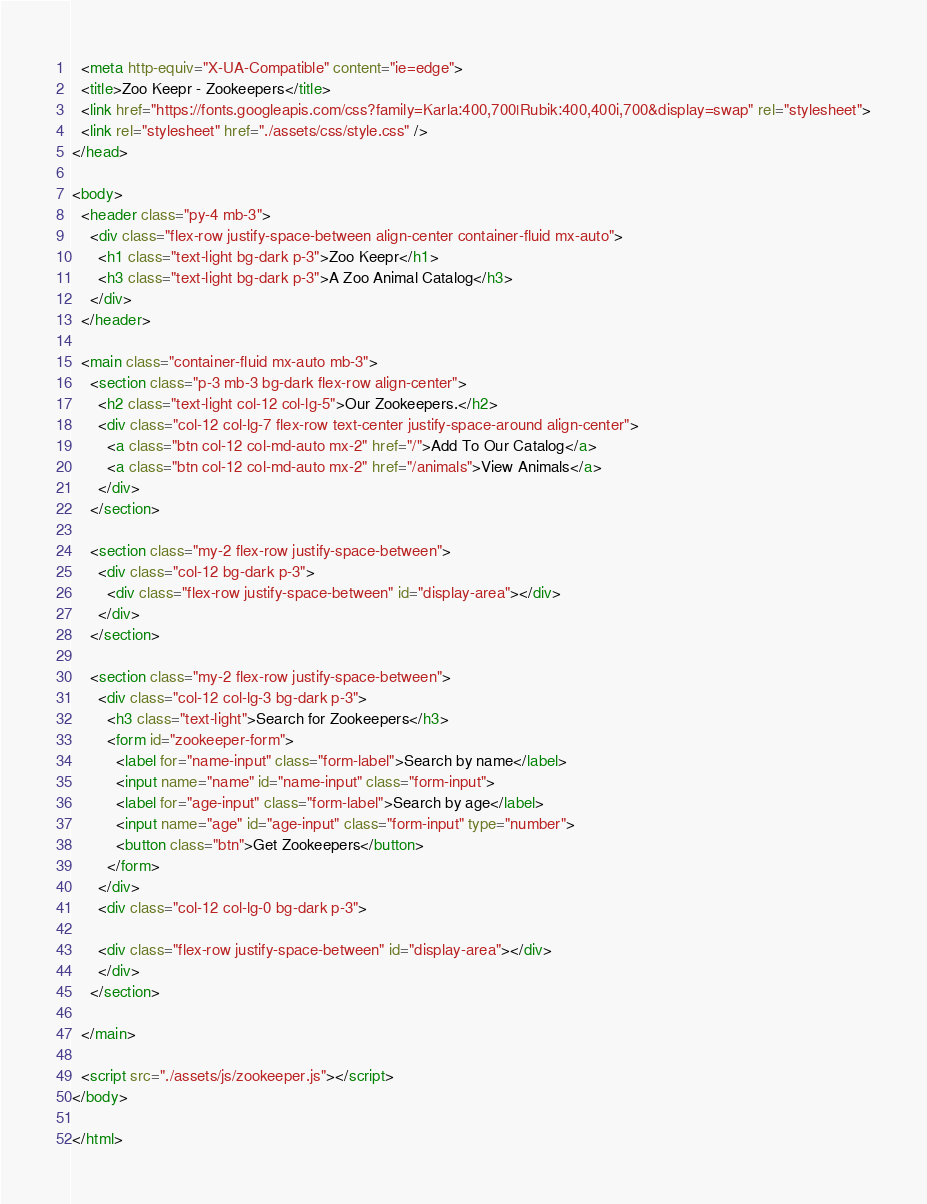Convert code to text. <code><loc_0><loc_0><loc_500><loc_500><_HTML_>  <meta http-equiv="X-UA-Compatible" content="ie=edge">
  <title>Zoo Keepr - Zookeepers</title>
  <link href="https://fonts.googleapis.com/css?family=Karla:400,700|Rubik:400,400i,700&display=swap" rel="stylesheet">
  <link rel="stylesheet" href="./assets/css/style.css" />
</head>

<body>
  <header class="py-4 mb-3">
    <div class="flex-row justify-space-between align-center container-fluid mx-auto">
      <h1 class="text-light bg-dark p-3">Zoo Keepr</h1>
      <h3 class="text-light bg-dark p-3">A Zoo Animal Catalog</h3>
    </div>
  </header>

  <main class="container-fluid mx-auto mb-3">
    <section class="p-3 mb-3 bg-dark flex-row align-center">
      <h2 class="text-light col-12 col-lg-5">Our Zookeepers.</h2>
      <div class="col-12 col-lg-7 flex-row text-center justify-space-around align-center">
        <a class="btn col-12 col-md-auto mx-2" href="/">Add To Our Catalog</a>
        <a class="btn col-12 col-md-auto mx-2" href="/animals">View Animals</a>
      </div>
    </section>

    <section class="my-2 flex-row justify-space-between">
      <div class="col-12 bg-dark p-3">
        <div class="flex-row justify-space-between" id="display-area"></div>
      </div>
    </section>

    <section class="my-2 flex-row justify-space-between">
      <div class="col-12 col-lg-3 bg-dark p-3">
        <h3 class="text-light">Search for Zookeepers</h3>
        <form id="zookeeper-form">
          <label for="name-input" class="form-label">Search by name</label>
          <input name="name" id="name-input" class="form-input">
          <label for="age-input" class="form-label">Search by age</label>
          <input name="age" id="age-input" class="form-input" type="number">
          <button class="btn">Get Zookeepers</button>
        </form>
      </div>
      <div class="col-12 col-lg-0 bg-dark p-3">

      <div class="flex-row justify-space-between" id="display-area"></div> 
      </div>
    </section>

  </main>

  <script src="./assets/js/zookeeper.js"></script>
</body>

</html></code> 